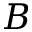Convert formula to latex. <formula><loc_0><loc_0><loc_500><loc_500>B</formula> 